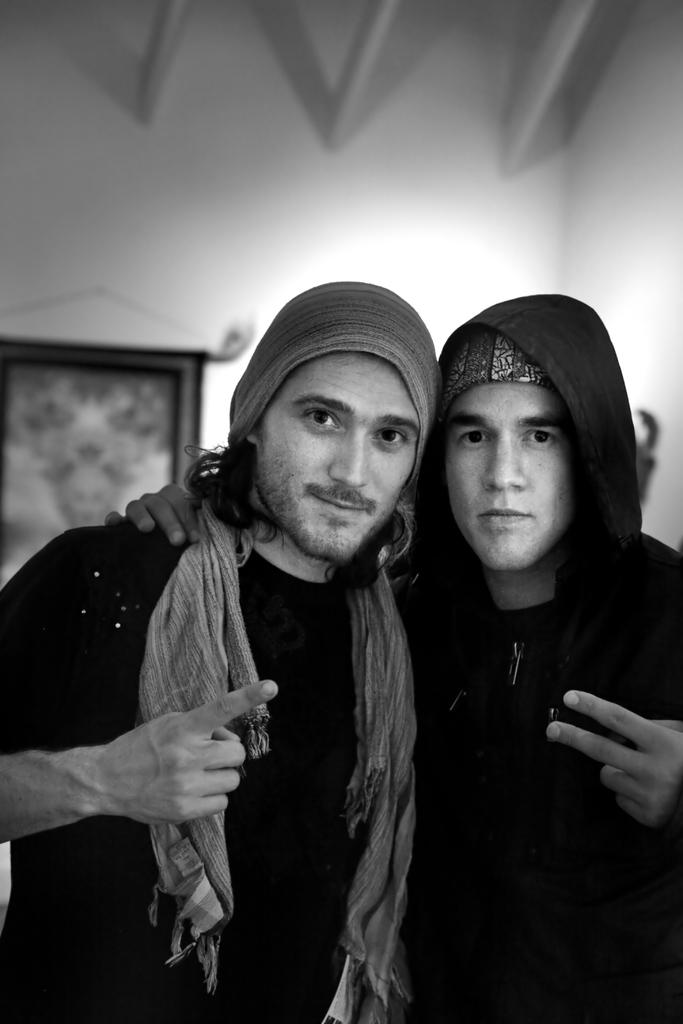How many people are present in the image? There are two people standing in the image. Can you describe the background of the image? There is a photo frame on the wall in the background of the image. What type of butter is being used by the people in the image? There is no butter present in the image; it only features two people standing and a photo frame on the wall. 